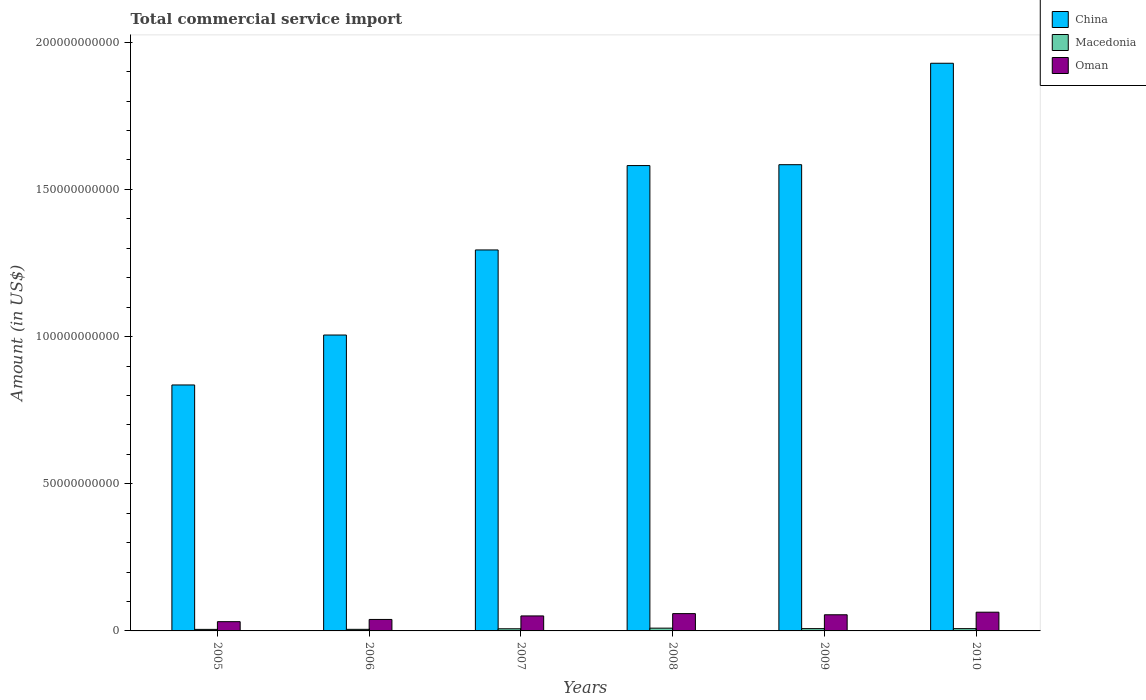How many bars are there on the 2nd tick from the left?
Your answer should be compact. 3. How many bars are there on the 1st tick from the right?
Offer a terse response. 3. What is the label of the 4th group of bars from the left?
Offer a terse response. 2008. What is the total commercial service import in China in 2005?
Provide a succinct answer. 8.36e+1. Across all years, what is the maximum total commercial service import in China?
Provide a short and direct response. 1.93e+11. Across all years, what is the minimum total commercial service import in China?
Your answer should be very brief. 8.36e+1. In which year was the total commercial service import in Oman maximum?
Provide a short and direct response. 2010. In which year was the total commercial service import in Oman minimum?
Make the answer very short. 2005. What is the total total commercial service import in Macedonia in the graph?
Provide a short and direct response. 4.29e+09. What is the difference between the total commercial service import in Macedonia in 2007 and that in 2010?
Provide a succinct answer. -5.05e+07. What is the difference between the total commercial service import in Oman in 2007 and the total commercial service import in China in 2006?
Your answer should be very brief. -9.54e+1. What is the average total commercial service import in Macedonia per year?
Offer a very short reply. 7.15e+08. In the year 2010, what is the difference between the total commercial service import in Macedonia and total commercial service import in China?
Offer a terse response. -1.92e+11. What is the ratio of the total commercial service import in Oman in 2008 to that in 2010?
Offer a very short reply. 0.92. Is the total commercial service import in Oman in 2005 less than that in 2007?
Give a very brief answer. Yes. Is the difference between the total commercial service import in Macedonia in 2005 and 2006 greater than the difference between the total commercial service import in China in 2005 and 2006?
Keep it short and to the point. Yes. What is the difference between the highest and the second highest total commercial service import in Oman?
Provide a short and direct response. 4.85e+08. What is the difference between the highest and the lowest total commercial service import in Oman?
Offer a very short reply. 3.22e+09. Is the sum of the total commercial service import in China in 2007 and 2010 greater than the maximum total commercial service import in Oman across all years?
Make the answer very short. Yes. What does the 1st bar from the left in 2005 represents?
Your response must be concise. China. What does the 1st bar from the right in 2009 represents?
Offer a terse response. Oman. Is it the case that in every year, the sum of the total commercial service import in Macedonia and total commercial service import in China is greater than the total commercial service import in Oman?
Offer a terse response. Yes. Does the graph contain any zero values?
Your response must be concise. No. What is the title of the graph?
Offer a terse response. Total commercial service import. What is the label or title of the X-axis?
Provide a succinct answer. Years. What is the Amount (in US$) in China in 2005?
Offer a very short reply. 8.36e+1. What is the Amount (in US$) in Macedonia in 2005?
Your answer should be very brief. 5.23e+08. What is the Amount (in US$) in Oman in 2005?
Your answer should be very brief. 3.15e+09. What is the Amount (in US$) in China in 2006?
Keep it short and to the point. 1.01e+11. What is the Amount (in US$) in Macedonia in 2006?
Offer a terse response. 5.38e+08. What is the Amount (in US$) in Oman in 2006?
Your answer should be compact. 3.90e+09. What is the Amount (in US$) in China in 2007?
Give a very brief answer. 1.29e+11. What is the Amount (in US$) in Macedonia in 2007?
Provide a succinct answer. 7.27e+08. What is the Amount (in US$) in Oman in 2007?
Make the answer very short. 5.09e+09. What is the Amount (in US$) in China in 2008?
Give a very brief answer. 1.58e+11. What is the Amount (in US$) in Macedonia in 2008?
Your answer should be very brief. 9.42e+08. What is the Amount (in US$) of Oman in 2008?
Your answer should be very brief. 5.88e+09. What is the Amount (in US$) of China in 2009?
Make the answer very short. 1.58e+11. What is the Amount (in US$) in Macedonia in 2009?
Ensure brevity in your answer.  7.84e+08. What is the Amount (in US$) in Oman in 2009?
Keep it short and to the point. 5.48e+09. What is the Amount (in US$) of China in 2010?
Offer a very short reply. 1.93e+11. What is the Amount (in US$) of Macedonia in 2010?
Your answer should be compact. 7.78e+08. What is the Amount (in US$) in Oman in 2010?
Provide a short and direct response. 6.36e+09. Across all years, what is the maximum Amount (in US$) in China?
Your response must be concise. 1.93e+11. Across all years, what is the maximum Amount (in US$) in Macedonia?
Provide a succinct answer. 9.42e+08. Across all years, what is the maximum Amount (in US$) in Oman?
Provide a short and direct response. 6.36e+09. Across all years, what is the minimum Amount (in US$) of China?
Your answer should be very brief. 8.36e+1. Across all years, what is the minimum Amount (in US$) of Macedonia?
Your answer should be very brief. 5.23e+08. Across all years, what is the minimum Amount (in US$) in Oman?
Provide a short and direct response. 3.15e+09. What is the total Amount (in US$) in China in the graph?
Offer a terse response. 8.23e+11. What is the total Amount (in US$) of Macedonia in the graph?
Provide a short and direct response. 4.29e+09. What is the total Amount (in US$) of Oman in the graph?
Your answer should be very brief. 2.99e+1. What is the difference between the Amount (in US$) in China in 2005 and that in 2006?
Keep it short and to the point. -1.70e+1. What is the difference between the Amount (in US$) in Macedonia in 2005 and that in 2006?
Your answer should be compact. -1.52e+07. What is the difference between the Amount (in US$) of Oman in 2005 and that in 2006?
Your response must be concise. -7.51e+08. What is the difference between the Amount (in US$) of China in 2005 and that in 2007?
Offer a terse response. -4.59e+1. What is the difference between the Amount (in US$) of Macedonia in 2005 and that in 2007?
Provide a short and direct response. -2.04e+08. What is the difference between the Amount (in US$) in Oman in 2005 and that in 2007?
Offer a very short reply. -1.95e+09. What is the difference between the Amount (in US$) of China in 2005 and that in 2008?
Your answer should be very brief. -7.45e+1. What is the difference between the Amount (in US$) in Macedonia in 2005 and that in 2008?
Provide a succinct answer. -4.18e+08. What is the difference between the Amount (in US$) in Oman in 2005 and that in 2008?
Your answer should be very brief. -2.73e+09. What is the difference between the Amount (in US$) in China in 2005 and that in 2009?
Provide a short and direct response. -7.48e+1. What is the difference between the Amount (in US$) of Macedonia in 2005 and that in 2009?
Your answer should be compact. -2.61e+08. What is the difference between the Amount (in US$) in Oman in 2005 and that in 2009?
Your answer should be very brief. -2.34e+09. What is the difference between the Amount (in US$) in China in 2005 and that in 2010?
Make the answer very short. -1.09e+11. What is the difference between the Amount (in US$) in Macedonia in 2005 and that in 2010?
Offer a very short reply. -2.55e+08. What is the difference between the Amount (in US$) in Oman in 2005 and that in 2010?
Make the answer very short. -3.22e+09. What is the difference between the Amount (in US$) of China in 2006 and that in 2007?
Offer a very short reply. -2.89e+1. What is the difference between the Amount (in US$) in Macedonia in 2006 and that in 2007?
Provide a short and direct response. -1.89e+08. What is the difference between the Amount (in US$) in Oman in 2006 and that in 2007?
Give a very brief answer. -1.20e+09. What is the difference between the Amount (in US$) in China in 2006 and that in 2008?
Offer a terse response. -5.76e+1. What is the difference between the Amount (in US$) of Macedonia in 2006 and that in 2008?
Keep it short and to the point. -4.03e+08. What is the difference between the Amount (in US$) of Oman in 2006 and that in 2008?
Provide a short and direct response. -1.98e+09. What is the difference between the Amount (in US$) in China in 2006 and that in 2009?
Your answer should be compact. -5.79e+1. What is the difference between the Amount (in US$) in Macedonia in 2006 and that in 2009?
Your answer should be compact. -2.46e+08. What is the difference between the Amount (in US$) in Oman in 2006 and that in 2009?
Your answer should be compact. -1.59e+09. What is the difference between the Amount (in US$) of China in 2006 and that in 2010?
Give a very brief answer. -9.23e+1. What is the difference between the Amount (in US$) of Macedonia in 2006 and that in 2010?
Your answer should be very brief. -2.40e+08. What is the difference between the Amount (in US$) of Oman in 2006 and that in 2010?
Provide a succinct answer. -2.47e+09. What is the difference between the Amount (in US$) in China in 2007 and that in 2008?
Give a very brief answer. -2.87e+1. What is the difference between the Amount (in US$) of Macedonia in 2007 and that in 2008?
Offer a very short reply. -2.14e+08. What is the difference between the Amount (in US$) in Oman in 2007 and that in 2008?
Ensure brevity in your answer.  -7.83e+08. What is the difference between the Amount (in US$) in China in 2007 and that in 2009?
Offer a very short reply. -2.90e+1. What is the difference between the Amount (in US$) in Macedonia in 2007 and that in 2009?
Provide a short and direct response. -5.70e+07. What is the difference between the Amount (in US$) of Oman in 2007 and that in 2009?
Provide a short and direct response. -3.89e+08. What is the difference between the Amount (in US$) of China in 2007 and that in 2010?
Provide a short and direct response. -6.34e+1. What is the difference between the Amount (in US$) of Macedonia in 2007 and that in 2010?
Offer a terse response. -5.05e+07. What is the difference between the Amount (in US$) of Oman in 2007 and that in 2010?
Make the answer very short. -1.27e+09. What is the difference between the Amount (in US$) of China in 2008 and that in 2009?
Keep it short and to the point. -2.95e+08. What is the difference between the Amount (in US$) in Macedonia in 2008 and that in 2009?
Give a very brief answer. 1.57e+08. What is the difference between the Amount (in US$) of Oman in 2008 and that in 2009?
Offer a very short reply. 3.94e+08. What is the difference between the Amount (in US$) in China in 2008 and that in 2010?
Your response must be concise. -3.48e+1. What is the difference between the Amount (in US$) of Macedonia in 2008 and that in 2010?
Offer a terse response. 1.64e+08. What is the difference between the Amount (in US$) of Oman in 2008 and that in 2010?
Your answer should be compact. -4.85e+08. What is the difference between the Amount (in US$) of China in 2009 and that in 2010?
Give a very brief answer. -3.45e+1. What is the difference between the Amount (in US$) of Macedonia in 2009 and that in 2010?
Your response must be concise. 6.47e+06. What is the difference between the Amount (in US$) in Oman in 2009 and that in 2010?
Offer a terse response. -8.80e+08. What is the difference between the Amount (in US$) of China in 2005 and the Amount (in US$) of Macedonia in 2006?
Make the answer very short. 8.30e+1. What is the difference between the Amount (in US$) of China in 2005 and the Amount (in US$) of Oman in 2006?
Keep it short and to the point. 7.97e+1. What is the difference between the Amount (in US$) of Macedonia in 2005 and the Amount (in US$) of Oman in 2006?
Keep it short and to the point. -3.37e+09. What is the difference between the Amount (in US$) of China in 2005 and the Amount (in US$) of Macedonia in 2007?
Your answer should be very brief. 8.28e+1. What is the difference between the Amount (in US$) in China in 2005 and the Amount (in US$) in Oman in 2007?
Your answer should be very brief. 7.85e+1. What is the difference between the Amount (in US$) of Macedonia in 2005 and the Amount (in US$) of Oman in 2007?
Your response must be concise. -4.57e+09. What is the difference between the Amount (in US$) in China in 2005 and the Amount (in US$) in Macedonia in 2008?
Make the answer very short. 8.26e+1. What is the difference between the Amount (in US$) of China in 2005 and the Amount (in US$) of Oman in 2008?
Make the answer very short. 7.77e+1. What is the difference between the Amount (in US$) in Macedonia in 2005 and the Amount (in US$) in Oman in 2008?
Your answer should be compact. -5.35e+09. What is the difference between the Amount (in US$) in China in 2005 and the Amount (in US$) in Macedonia in 2009?
Ensure brevity in your answer.  8.28e+1. What is the difference between the Amount (in US$) of China in 2005 and the Amount (in US$) of Oman in 2009?
Keep it short and to the point. 7.81e+1. What is the difference between the Amount (in US$) in Macedonia in 2005 and the Amount (in US$) in Oman in 2009?
Your answer should be compact. -4.96e+09. What is the difference between the Amount (in US$) in China in 2005 and the Amount (in US$) in Macedonia in 2010?
Provide a short and direct response. 8.28e+1. What is the difference between the Amount (in US$) of China in 2005 and the Amount (in US$) of Oman in 2010?
Make the answer very short. 7.72e+1. What is the difference between the Amount (in US$) in Macedonia in 2005 and the Amount (in US$) in Oman in 2010?
Ensure brevity in your answer.  -5.84e+09. What is the difference between the Amount (in US$) in China in 2006 and the Amount (in US$) in Macedonia in 2007?
Keep it short and to the point. 9.98e+1. What is the difference between the Amount (in US$) of China in 2006 and the Amount (in US$) of Oman in 2007?
Your answer should be compact. 9.54e+1. What is the difference between the Amount (in US$) in Macedonia in 2006 and the Amount (in US$) in Oman in 2007?
Your answer should be very brief. -4.56e+09. What is the difference between the Amount (in US$) in China in 2006 and the Amount (in US$) in Macedonia in 2008?
Provide a short and direct response. 9.96e+1. What is the difference between the Amount (in US$) in China in 2006 and the Amount (in US$) in Oman in 2008?
Provide a succinct answer. 9.47e+1. What is the difference between the Amount (in US$) of Macedonia in 2006 and the Amount (in US$) of Oman in 2008?
Make the answer very short. -5.34e+09. What is the difference between the Amount (in US$) in China in 2006 and the Amount (in US$) in Macedonia in 2009?
Keep it short and to the point. 9.97e+1. What is the difference between the Amount (in US$) in China in 2006 and the Amount (in US$) in Oman in 2009?
Your response must be concise. 9.50e+1. What is the difference between the Amount (in US$) in Macedonia in 2006 and the Amount (in US$) in Oman in 2009?
Give a very brief answer. -4.95e+09. What is the difference between the Amount (in US$) of China in 2006 and the Amount (in US$) of Macedonia in 2010?
Provide a short and direct response. 9.98e+1. What is the difference between the Amount (in US$) in China in 2006 and the Amount (in US$) in Oman in 2010?
Provide a succinct answer. 9.42e+1. What is the difference between the Amount (in US$) of Macedonia in 2006 and the Amount (in US$) of Oman in 2010?
Provide a short and direct response. -5.82e+09. What is the difference between the Amount (in US$) in China in 2007 and the Amount (in US$) in Macedonia in 2008?
Provide a short and direct response. 1.28e+11. What is the difference between the Amount (in US$) of China in 2007 and the Amount (in US$) of Oman in 2008?
Make the answer very short. 1.24e+11. What is the difference between the Amount (in US$) of Macedonia in 2007 and the Amount (in US$) of Oman in 2008?
Make the answer very short. -5.15e+09. What is the difference between the Amount (in US$) of China in 2007 and the Amount (in US$) of Macedonia in 2009?
Your answer should be compact. 1.29e+11. What is the difference between the Amount (in US$) in China in 2007 and the Amount (in US$) in Oman in 2009?
Offer a very short reply. 1.24e+11. What is the difference between the Amount (in US$) of Macedonia in 2007 and the Amount (in US$) of Oman in 2009?
Offer a very short reply. -4.76e+09. What is the difference between the Amount (in US$) in China in 2007 and the Amount (in US$) in Macedonia in 2010?
Provide a succinct answer. 1.29e+11. What is the difference between the Amount (in US$) of China in 2007 and the Amount (in US$) of Oman in 2010?
Ensure brevity in your answer.  1.23e+11. What is the difference between the Amount (in US$) of Macedonia in 2007 and the Amount (in US$) of Oman in 2010?
Offer a terse response. -5.64e+09. What is the difference between the Amount (in US$) of China in 2008 and the Amount (in US$) of Macedonia in 2009?
Give a very brief answer. 1.57e+11. What is the difference between the Amount (in US$) in China in 2008 and the Amount (in US$) in Oman in 2009?
Provide a short and direct response. 1.53e+11. What is the difference between the Amount (in US$) in Macedonia in 2008 and the Amount (in US$) in Oman in 2009?
Provide a succinct answer. -4.54e+09. What is the difference between the Amount (in US$) of China in 2008 and the Amount (in US$) of Macedonia in 2010?
Give a very brief answer. 1.57e+11. What is the difference between the Amount (in US$) in China in 2008 and the Amount (in US$) in Oman in 2010?
Give a very brief answer. 1.52e+11. What is the difference between the Amount (in US$) in Macedonia in 2008 and the Amount (in US$) in Oman in 2010?
Give a very brief answer. -5.42e+09. What is the difference between the Amount (in US$) in China in 2009 and the Amount (in US$) in Macedonia in 2010?
Provide a succinct answer. 1.58e+11. What is the difference between the Amount (in US$) of China in 2009 and the Amount (in US$) of Oman in 2010?
Keep it short and to the point. 1.52e+11. What is the difference between the Amount (in US$) of Macedonia in 2009 and the Amount (in US$) of Oman in 2010?
Offer a terse response. -5.58e+09. What is the average Amount (in US$) in China per year?
Offer a terse response. 1.37e+11. What is the average Amount (in US$) in Macedonia per year?
Your answer should be compact. 7.15e+08. What is the average Amount (in US$) in Oman per year?
Offer a very short reply. 4.98e+09. In the year 2005, what is the difference between the Amount (in US$) in China and Amount (in US$) in Macedonia?
Provide a succinct answer. 8.30e+1. In the year 2005, what is the difference between the Amount (in US$) of China and Amount (in US$) of Oman?
Your answer should be very brief. 8.04e+1. In the year 2005, what is the difference between the Amount (in US$) of Macedonia and Amount (in US$) of Oman?
Provide a succinct answer. -2.62e+09. In the year 2006, what is the difference between the Amount (in US$) in China and Amount (in US$) in Macedonia?
Keep it short and to the point. 1.00e+11. In the year 2006, what is the difference between the Amount (in US$) in China and Amount (in US$) in Oman?
Your answer should be very brief. 9.66e+1. In the year 2006, what is the difference between the Amount (in US$) of Macedonia and Amount (in US$) of Oman?
Provide a succinct answer. -3.36e+09. In the year 2007, what is the difference between the Amount (in US$) of China and Amount (in US$) of Macedonia?
Provide a short and direct response. 1.29e+11. In the year 2007, what is the difference between the Amount (in US$) of China and Amount (in US$) of Oman?
Give a very brief answer. 1.24e+11. In the year 2007, what is the difference between the Amount (in US$) of Macedonia and Amount (in US$) of Oman?
Provide a succinct answer. -4.37e+09. In the year 2008, what is the difference between the Amount (in US$) of China and Amount (in US$) of Macedonia?
Your answer should be compact. 1.57e+11. In the year 2008, what is the difference between the Amount (in US$) in China and Amount (in US$) in Oman?
Your response must be concise. 1.52e+11. In the year 2008, what is the difference between the Amount (in US$) in Macedonia and Amount (in US$) in Oman?
Make the answer very short. -4.94e+09. In the year 2009, what is the difference between the Amount (in US$) of China and Amount (in US$) of Macedonia?
Ensure brevity in your answer.  1.58e+11. In the year 2009, what is the difference between the Amount (in US$) in China and Amount (in US$) in Oman?
Provide a succinct answer. 1.53e+11. In the year 2009, what is the difference between the Amount (in US$) in Macedonia and Amount (in US$) in Oman?
Give a very brief answer. -4.70e+09. In the year 2010, what is the difference between the Amount (in US$) in China and Amount (in US$) in Macedonia?
Offer a terse response. 1.92e+11. In the year 2010, what is the difference between the Amount (in US$) in China and Amount (in US$) in Oman?
Offer a very short reply. 1.86e+11. In the year 2010, what is the difference between the Amount (in US$) in Macedonia and Amount (in US$) in Oman?
Ensure brevity in your answer.  -5.59e+09. What is the ratio of the Amount (in US$) of China in 2005 to that in 2006?
Provide a succinct answer. 0.83. What is the ratio of the Amount (in US$) in Macedonia in 2005 to that in 2006?
Give a very brief answer. 0.97. What is the ratio of the Amount (in US$) in Oman in 2005 to that in 2006?
Ensure brevity in your answer.  0.81. What is the ratio of the Amount (in US$) of China in 2005 to that in 2007?
Give a very brief answer. 0.65. What is the ratio of the Amount (in US$) of Macedonia in 2005 to that in 2007?
Make the answer very short. 0.72. What is the ratio of the Amount (in US$) in Oman in 2005 to that in 2007?
Your response must be concise. 0.62. What is the ratio of the Amount (in US$) of China in 2005 to that in 2008?
Your response must be concise. 0.53. What is the ratio of the Amount (in US$) in Macedonia in 2005 to that in 2008?
Provide a short and direct response. 0.56. What is the ratio of the Amount (in US$) in Oman in 2005 to that in 2008?
Provide a succinct answer. 0.54. What is the ratio of the Amount (in US$) of China in 2005 to that in 2009?
Your answer should be compact. 0.53. What is the ratio of the Amount (in US$) in Macedonia in 2005 to that in 2009?
Keep it short and to the point. 0.67. What is the ratio of the Amount (in US$) in Oman in 2005 to that in 2009?
Your response must be concise. 0.57. What is the ratio of the Amount (in US$) in China in 2005 to that in 2010?
Offer a very short reply. 0.43. What is the ratio of the Amount (in US$) of Macedonia in 2005 to that in 2010?
Make the answer very short. 0.67. What is the ratio of the Amount (in US$) of Oman in 2005 to that in 2010?
Provide a short and direct response. 0.49. What is the ratio of the Amount (in US$) of China in 2006 to that in 2007?
Make the answer very short. 0.78. What is the ratio of the Amount (in US$) of Macedonia in 2006 to that in 2007?
Your answer should be compact. 0.74. What is the ratio of the Amount (in US$) in Oman in 2006 to that in 2007?
Your answer should be very brief. 0.76. What is the ratio of the Amount (in US$) in China in 2006 to that in 2008?
Keep it short and to the point. 0.64. What is the ratio of the Amount (in US$) in Macedonia in 2006 to that in 2008?
Your answer should be compact. 0.57. What is the ratio of the Amount (in US$) of Oman in 2006 to that in 2008?
Ensure brevity in your answer.  0.66. What is the ratio of the Amount (in US$) of China in 2006 to that in 2009?
Your answer should be very brief. 0.63. What is the ratio of the Amount (in US$) of Macedonia in 2006 to that in 2009?
Ensure brevity in your answer.  0.69. What is the ratio of the Amount (in US$) of Oman in 2006 to that in 2009?
Keep it short and to the point. 0.71. What is the ratio of the Amount (in US$) of China in 2006 to that in 2010?
Give a very brief answer. 0.52. What is the ratio of the Amount (in US$) in Macedonia in 2006 to that in 2010?
Provide a short and direct response. 0.69. What is the ratio of the Amount (in US$) of Oman in 2006 to that in 2010?
Your response must be concise. 0.61. What is the ratio of the Amount (in US$) of China in 2007 to that in 2008?
Your response must be concise. 0.82. What is the ratio of the Amount (in US$) of Macedonia in 2007 to that in 2008?
Offer a terse response. 0.77. What is the ratio of the Amount (in US$) of Oman in 2007 to that in 2008?
Offer a terse response. 0.87. What is the ratio of the Amount (in US$) of China in 2007 to that in 2009?
Your response must be concise. 0.82. What is the ratio of the Amount (in US$) in Macedonia in 2007 to that in 2009?
Ensure brevity in your answer.  0.93. What is the ratio of the Amount (in US$) of Oman in 2007 to that in 2009?
Keep it short and to the point. 0.93. What is the ratio of the Amount (in US$) in China in 2007 to that in 2010?
Your answer should be compact. 0.67. What is the ratio of the Amount (in US$) of Macedonia in 2007 to that in 2010?
Offer a very short reply. 0.94. What is the ratio of the Amount (in US$) of Oman in 2007 to that in 2010?
Give a very brief answer. 0.8. What is the ratio of the Amount (in US$) of China in 2008 to that in 2009?
Your answer should be compact. 1. What is the ratio of the Amount (in US$) in Macedonia in 2008 to that in 2009?
Ensure brevity in your answer.  1.2. What is the ratio of the Amount (in US$) of Oman in 2008 to that in 2009?
Provide a short and direct response. 1.07. What is the ratio of the Amount (in US$) in China in 2008 to that in 2010?
Offer a very short reply. 0.82. What is the ratio of the Amount (in US$) of Macedonia in 2008 to that in 2010?
Provide a succinct answer. 1.21. What is the ratio of the Amount (in US$) of Oman in 2008 to that in 2010?
Offer a terse response. 0.92. What is the ratio of the Amount (in US$) in China in 2009 to that in 2010?
Offer a terse response. 0.82. What is the ratio of the Amount (in US$) of Macedonia in 2009 to that in 2010?
Your answer should be very brief. 1.01. What is the ratio of the Amount (in US$) of Oman in 2009 to that in 2010?
Ensure brevity in your answer.  0.86. What is the difference between the highest and the second highest Amount (in US$) in China?
Offer a very short reply. 3.45e+1. What is the difference between the highest and the second highest Amount (in US$) of Macedonia?
Keep it short and to the point. 1.57e+08. What is the difference between the highest and the second highest Amount (in US$) in Oman?
Offer a terse response. 4.85e+08. What is the difference between the highest and the lowest Amount (in US$) of China?
Give a very brief answer. 1.09e+11. What is the difference between the highest and the lowest Amount (in US$) in Macedonia?
Your response must be concise. 4.18e+08. What is the difference between the highest and the lowest Amount (in US$) in Oman?
Make the answer very short. 3.22e+09. 